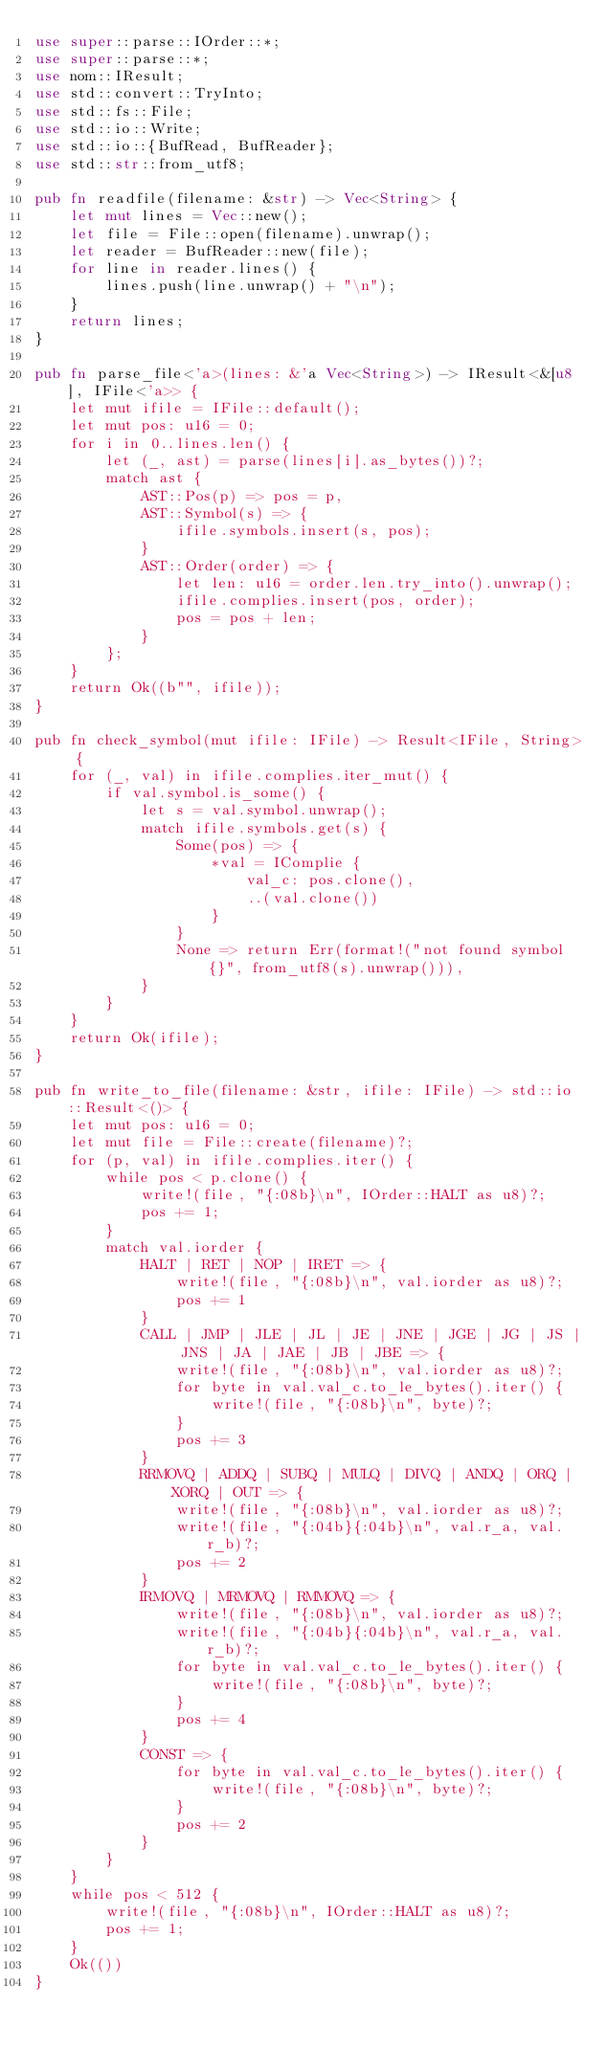Convert code to text. <code><loc_0><loc_0><loc_500><loc_500><_Rust_>use super::parse::IOrder::*;
use super::parse::*;
use nom::IResult;
use std::convert::TryInto;
use std::fs::File;
use std::io::Write;
use std::io::{BufRead, BufReader};
use std::str::from_utf8;

pub fn readfile(filename: &str) -> Vec<String> {
    let mut lines = Vec::new();
    let file = File::open(filename).unwrap();
    let reader = BufReader::new(file);
    for line in reader.lines() {
        lines.push(line.unwrap() + "\n");
    }
    return lines;
}

pub fn parse_file<'a>(lines: &'a Vec<String>) -> IResult<&[u8], IFile<'a>> {
    let mut ifile = IFile::default();
    let mut pos: u16 = 0;
    for i in 0..lines.len() {
        let (_, ast) = parse(lines[i].as_bytes())?;
        match ast {
            AST::Pos(p) => pos = p,
            AST::Symbol(s) => {
                ifile.symbols.insert(s, pos);
            }
            AST::Order(order) => {
                let len: u16 = order.len.try_into().unwrap();
                ifile.complies.insert(pos, order);
                pos = pos + len;
            }
        };
    }
    return Ok((b"", ifile));
}

pub fn check_symbol(mut ifile: IFile) -> Result<IFile, String> {
    for (_, val) in ifile.complies.iter_mut() {
        if val.symbol.is_some() {
            let s = val.symbol.unwrap();
            match ifile.symbols.get(s) {
                Some(pos) => {
                    *val = IComplie {
                        val_c: pos.clone(),
                        ..(val.clone())
                    }
                }
                None => return Err(format!("not found symbol {}", from_utf8(s).unwrap())),
            }
        }
    }
    return Ok(ifile);
}

pub fn write_to_file(filename: &str, ifile: IFile) -> std::io::Result<()> {
    let mut pos: u16 = 0;
    let mut file = File::create(filename)?;
    for (p, val) in ifile.complies.iter() {
        while pos < p.clone() {
            write!(file, "{:08b}\n", IOrder::HALT as u8)?;
            pos += 1;
        }
        match val.iorder {
            HALT | RET | NOP | IRET => {
                write!(file, "{:08b}\n", val.iorder as u8)?;
                pos += 1
            }
            CALL | JMP | JLE | JL | JE | JNE | JGE | JG | JS | JNS | JA | JAE | JB | JBE => {
                write!(file, "{:08b}\n", val.iorder as u8)?;
                for byte in val.val_c.to_le_bytes().iter() {
                    write!(file, "{:08b}\n", byte)?;
                }
                pos += 3
            }
            RRMOVQ | ADDQ | SUBQ | MULQ | DIVQ | ANDQ | ORQ | XORQ | OUT => {
                write!(file, "{:08b}\n", val.iorder as u8)?;
                write!(file, "{:04b}{:04b}\n", val.r_a, val.r_b)?;
                pos += 2
            }
            IRMOVQ | MRMOVQ | RMMOVQ => {
                write!(file, "{:08b}\n", val.iorder as u8)?;
                write!(file, "{:04b}{:04b}\n", val.r_a, val.r_b)?;
                for byte in val.val_c.to_le_bytes().iter() {
                    write!(file, "{:08b}\n", byte)?;
                }
                pos += 4
            }
            CONST => {
                for byte in val.val_c.to_le_bytes().iter() {
                    write!(file, "{:08b}\n", byte)?;
                }
                pos += 2
            }
        }
    }
    while pos < 512 {
        write!(file, "{:08b}\n", IOrder::HALT as u8)?;
        pos += 1;
    }
    Ok(())
}
</code> 